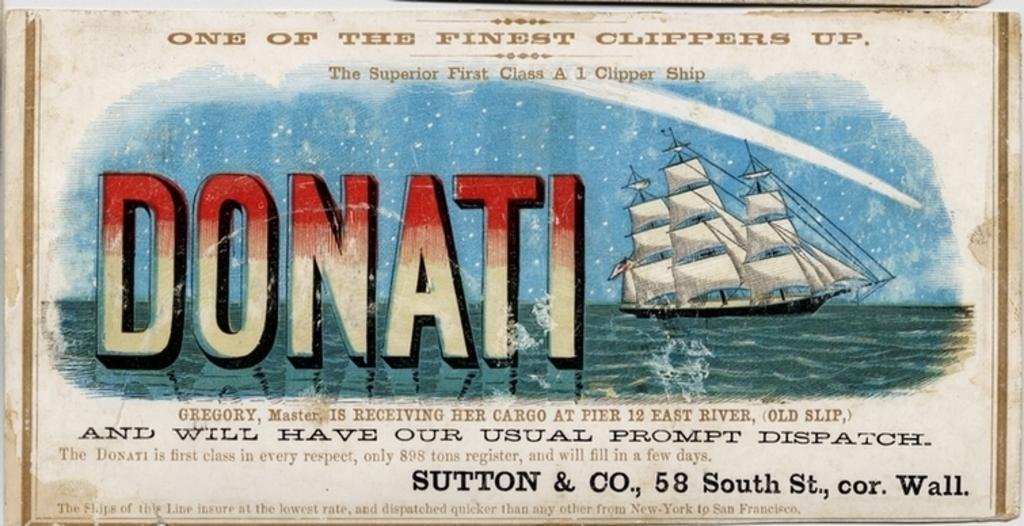In one or two sentences, can you explain what this image depicts? In this image, we can see a picture and there is PANATI printed, and there is a ship and there is water on the picture. 